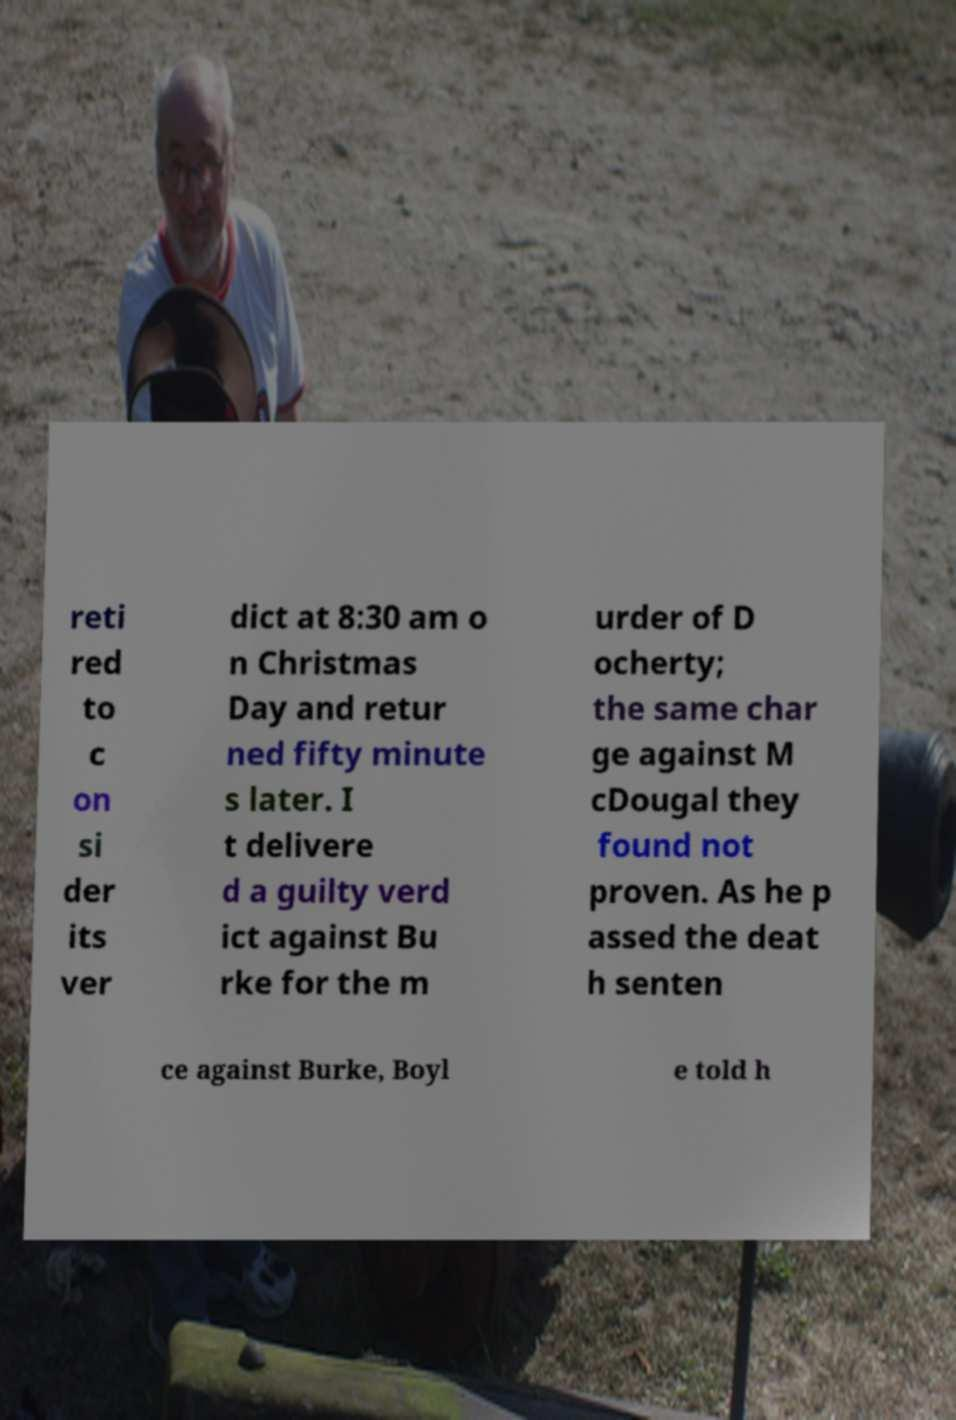Please identify and transcribe the text found in this image. reti red to c on si der its ver dict at 8:30 am o n Christmas Day and retur ned fifty minute s later. I t delivere d a guilty verd ict against Bu rke for the m urder of D ocherty; the same char ge against M cDougal they found not proven. As he p assed the deat h senten ce against Burke, Boyl e told h 